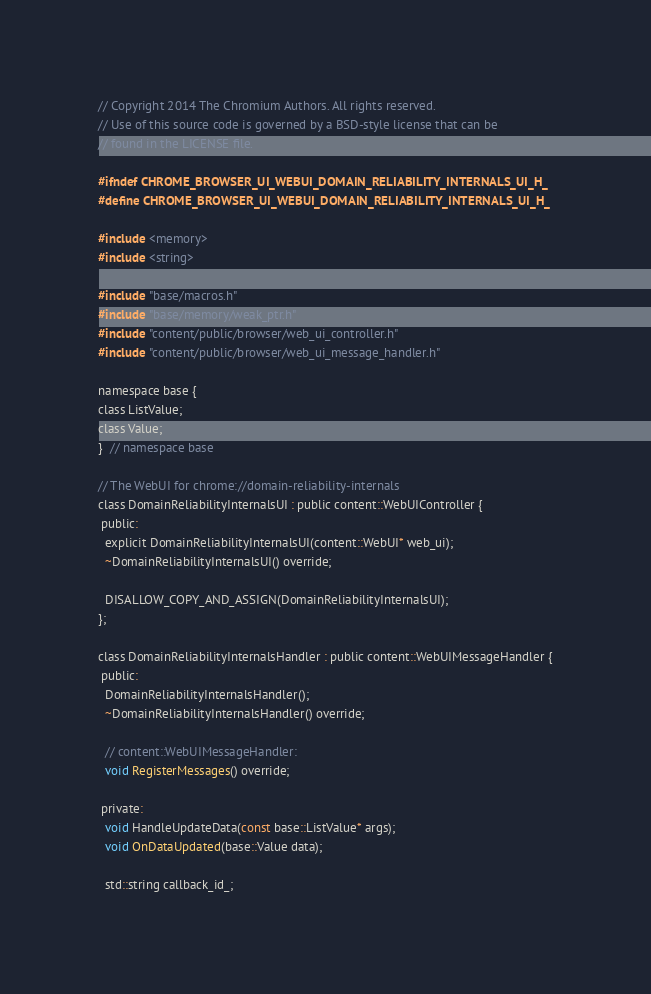Convert code to text. <code><loc_0><loc_0><loc_500><loc_500><_C_>// Copyright 2014 The Chromium Authors. All rights reserved.
// Use of this source code is governed by a BSD-style license that can be
// found in the LICENSE file.

#ifndef CHROME_BROWSER_UI_WEBUI_DOMAIN_RELIABILITY_INTERNALS_UI_H_
#define CHROME_BROWSER_UI_WEBUI_DOMAIN_RELIABILITY_INTERNALS_UI_H_

#include <memory>
#include <string>

#include "base/macros.h"
#include "base/memory/weak_ptr.h"
#include "content/public/browser/web_ui_controller.h"
#include "content/public/browser/web_ui_message_handler.h"

namespace base {
class ListValue;
class Value;
}  // namespace base

// The WebUI for chrome://domain-reliability-internals
class DomainReliabilityInternalsUI : public content::WebUIController {
 public:
  explicit DomainReliabilityInternalsUI(content::WebUI* web_ui);
  ~DomainReliabilityInternalsUI() override;

  DISALLOW_COPY_AND_ASSIGN(DomainReliabilityInternalsUI);
};

class DomainReliabilityInternalsHandler : public content::WebUIMessageHandler {
 public:
  DomainReliabilityInternalsHandler();
  ~DomainReliabilityInternalsHandler() override;

  // content::WebUIMessageHandler:
  void RegisterMessages() override;

 private:
  void HandleUpdateData(const base::ListValue* args);
  void OnDataUpdated(base::Value data);

  std::string callback_id_;</code> 